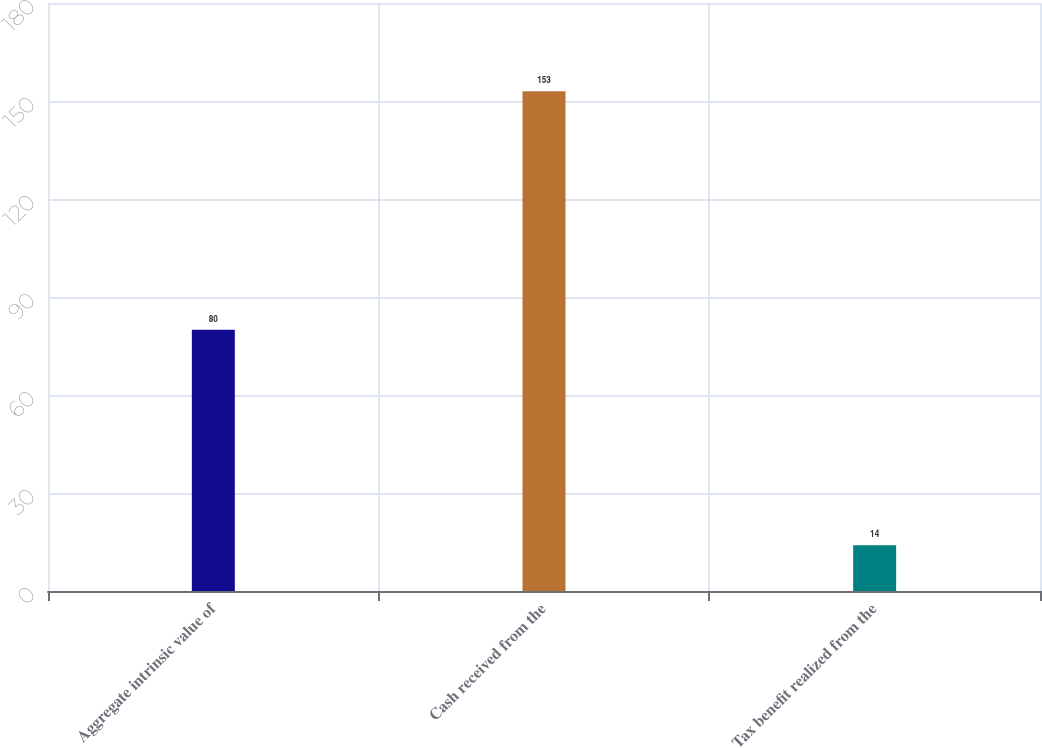<chart> <loc_0><loc_0><loc_500><loc_500><bar_chart><fcel>Aggregate intrinsic value of<fcel>Cash received from the<fcel>Tax benefit realized from the<nl><fcel>80<fcel>153<fcel>14<nl></chart> 